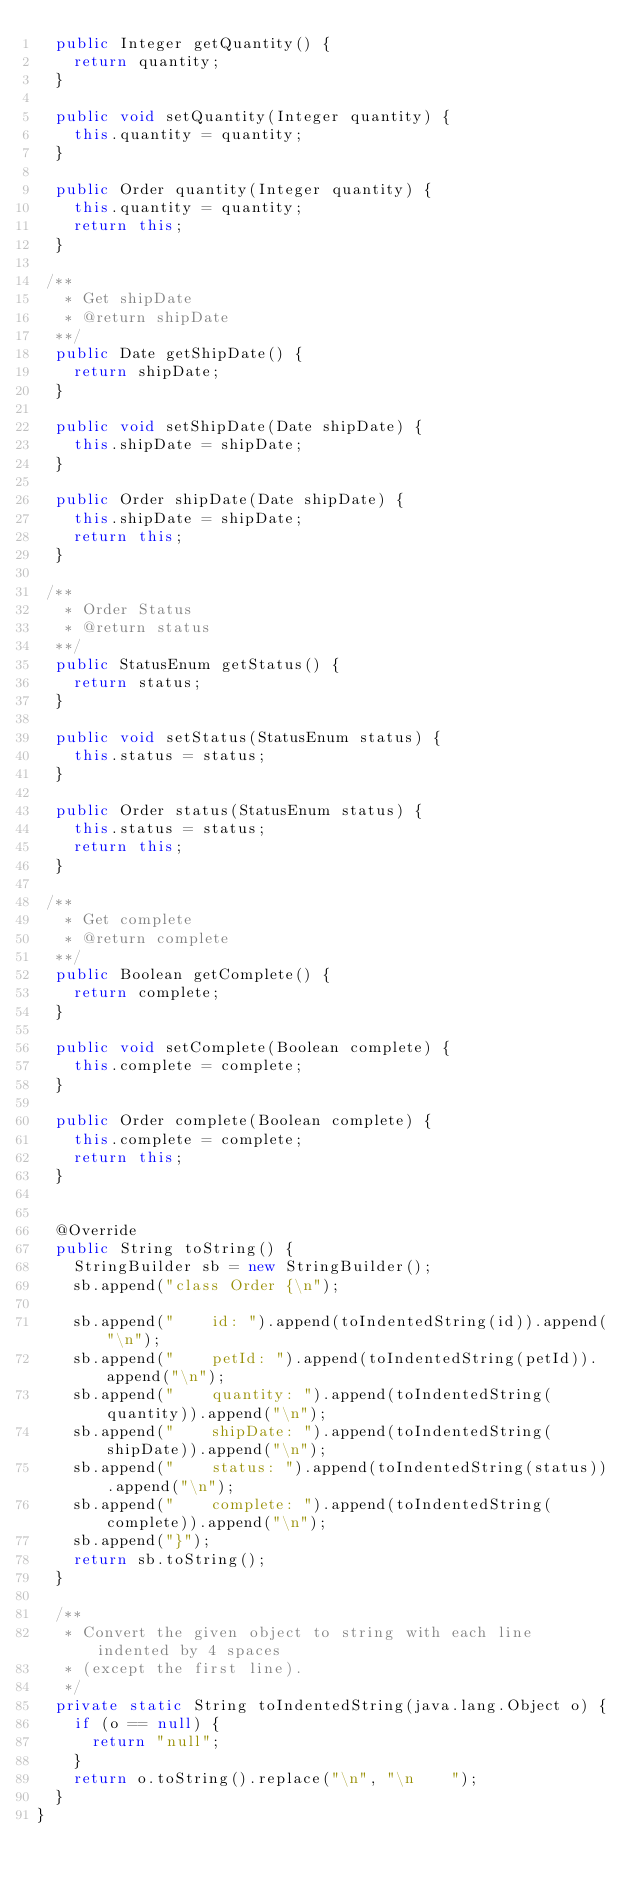Convert code to text. <code><loc_0><loc_0><loc_500><loc_500><_Java_>  public Integer getQuantity() {
    return quantity;
  }

  public void setQuantity(Integer quantity) {
    this.quantity = quantity;
  }

  public Order quantity(Integer quantity) {
    this.quantity = quantity;
    return this;
  }

 /**
   * Get shipDate
   * @return shipDate
  **/
  public Date getShipDate() {
    return shipDate;
  }

  public void setShipDate(Date shipDate) {
    this.shipDate = shipDate;
  }

  public Order shipDate(Date shipDate) {
    this.shipDate = shipDate;
    return this;
  }

 /**
   * Order Status
   * @return status
  **/
  public StatusEnum getStatus() {
    return status;
  }

  public void setStatus(StatusEnum status) {
    this.status = status;
  }

  public Order status(StatusEnum status) {
    this.status = status;
    return this;
  }

 /**
   * Get complete
   * @return complete
  **/
  public Boolean getComplete() {
    return complete;
  }

  public void setComplete(Boolean complete) {
    this.complete = complete;
  }

  public Order complete(Boolean complete) {
    this.complete = complete;
    return this;
  }


  @Override
  public String toString() {
    StringBuilder sb = new StringBuilder();
    sb.append("class Order {\n");
    
    sb.append("    id: ").append(toIndentedString(id)).append("\n");
    sb.append("    petId: ").append(toIndentedString(petId)).append("\n");
    sb.append("    quantity: ").append(toIndentedString(quantity)).append("\n");
    sb.append("    shipDate: ").append(toIndentedString(shipDate)).append("\n");
    sb.append("    status: ").append(toIndentedString(status)).append("\n");
    sb.append("    complete: ").append(toIndentedString(complete)).append("\n");
    sb.append("}");
    return sb.toString();
  }

  /**
   * Convert the given object to string with each line indented by 4 spaces
   * (except the first line).
   */
  private static String toIndentedString(java.lang.Object o) {
    if (o == null) {
      return "null";
    }
    return o.toString().replace("\n", "\n    ");
  }
}

</code> 